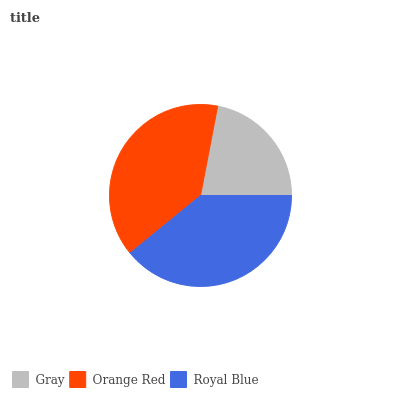Is Gray the minimum?
Answer yes or no. Yes. Is Royal Blue the maximum?
Answer yes or no. Yes. Is Orange Red the minimum?
Answer yes or no. No. Is Orange Red the maximum?
Answer yes or no. No. Is Orange Red greater than Gray?
Answer yes or no. Yes. Is Gray less than Orange Red?
Answer yes or no. Yes. Is Gray greater than Orange Red?
Answer yes or no. No. Is Orange Red less than Gray?
Answer yes or no. No. Is Orange Red the high median?
Answer yes or no. Yes. Is Orange Red the low median?
Answer yes or no. Yes. Is Royal Blue the high median?
Answer yes or no. No. Is Royal Blue the low median?
Answer yes or no. No. 